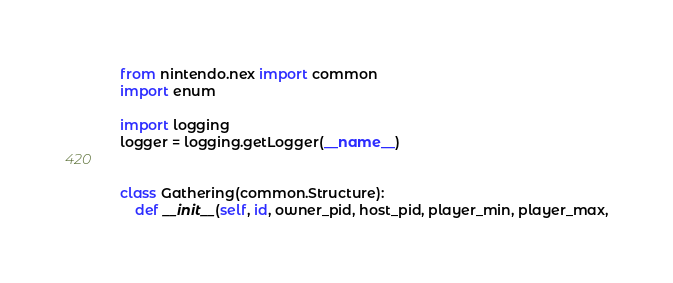<code> <loc_0><loc_0><loc_500><loc_500><_Python_>
from nintendo.nex import common
import enum

import logging
logger = logging.getLogger(__name__)


class Gathering(common.Structure):
	def __init__(self, id, owner_pid, host_pid, player_min, player_max,</code> 